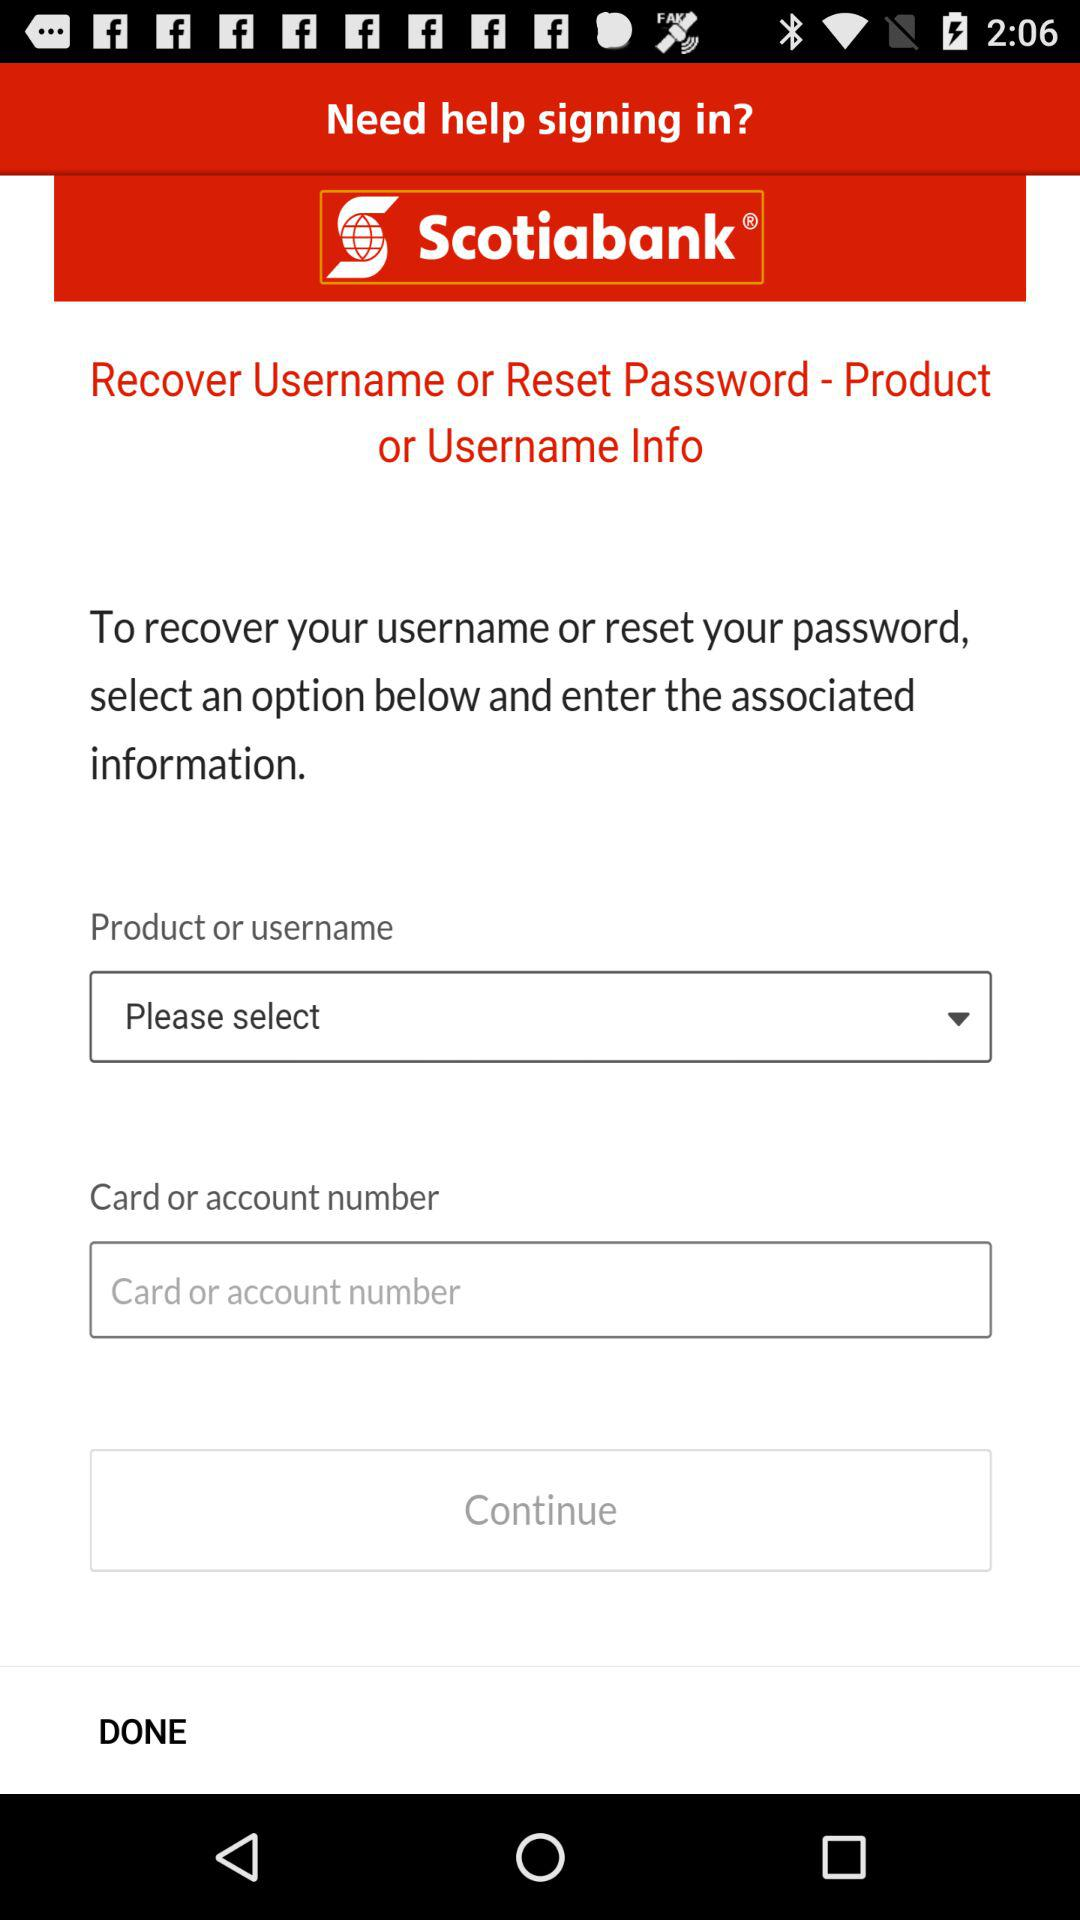What is the application name? The application name is "Scotiabank". 